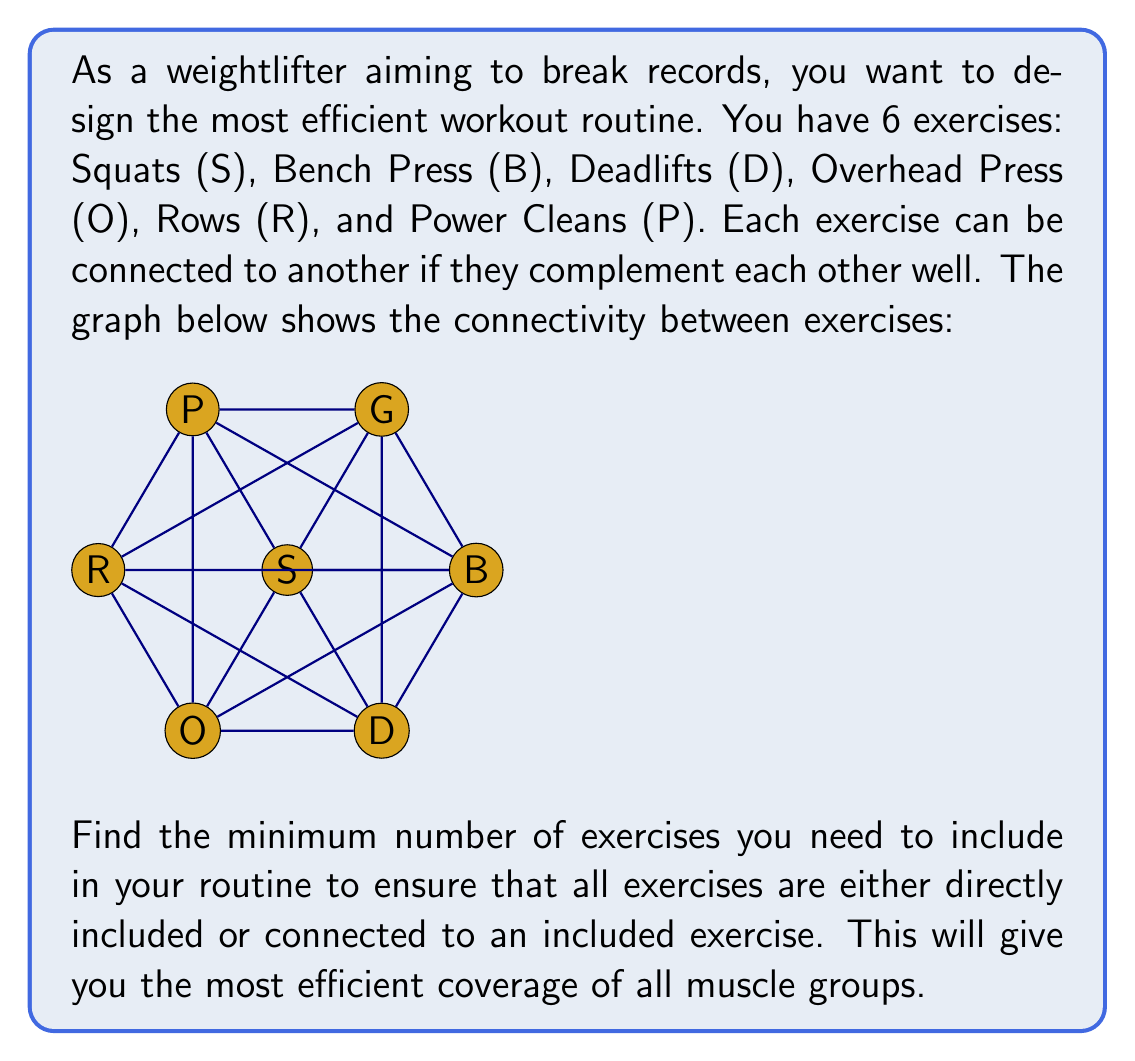Can you solve this math problem? To solve this problem, we need to find the minimum dominating set in the given graph. A dominating set is a subset of vertices in a graph such that every vertex not in the subset is adjacent to at least one vertex in the subset.

Let's approach this step-by-step:

1) First, we observe that no single exercise is connected to all others, so we need at least two exercises in our set.

2) Let's try to find a set of two exercises that dominate the graph:
   - S is connected to B, D, O, P
   - B is connected to S, D, R, P
   - D is connected to S, B, O, R
   - O is connected to S, D, R, P
   - R is connected to B, D, O, P
   - P is connected to S, B, O, R

3) We can see that S and R together are connected to all other exercises:
   - S covers B, D, O, P
   - R covers B, D, O, P
   - Together, they cover all 6 exercises

4) We can verify that no other pair of exercises covers all 6 exercises.

Therefore, the minimum dominating set for this graph consists of 2 vertices, which can be Squats (S) and Rows (R).

This means that by including Squats and Rows in your routine, you ensure that all other exercises are either directly included or connected to an included exercise, giving you the most efficient coverage of all muscle groups.
Answer: The minimum number of exercises needed is 2. One possible solution is to include Squats (S) and Rows (R) in the routine. 